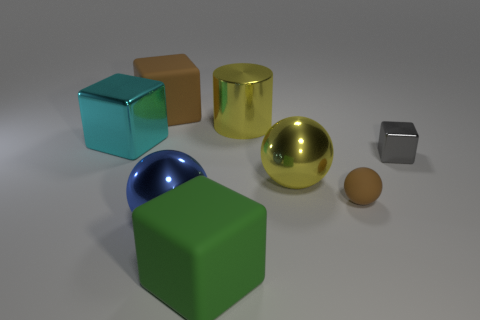How many other things are there of the same size as the yellow metal cylinder?
Provide a short and direct response. 5. The big metallic cube is what color?
Offer a terse response. Cyan. How many big things are cyan objects or brown objects?
Your response must be concise. 2. Is the size of the cyan thing that is on the left side of the yellow cylinder the same as the brown matte object behind the small brown sphere?
Make the answer very short. Yes. There is a brown matte thing that is the same shape as the small gray shiny object; what is its size?
Ensure brevity in your answer.  Large. Is the number of large green rubber blocks that are behind the tiny sphere greater than the number of large cubes that are behind the big blue shiny sphere?
Keep it short and to the point. No. The big object that is in front of the small ball and behind the big green block is made of what material?
Keep it short and to the point. Metal. The other metal thing that is the same shape as the small metallic object is what color?
Provide a succinct answer. Cyan. The gray metal block is what size?
Your answer should be compact. Small. There is a metallic ball that is right of the matte cube in front of the tiny gray cube; what is its color?
Give a very brief answer. Yellow. 